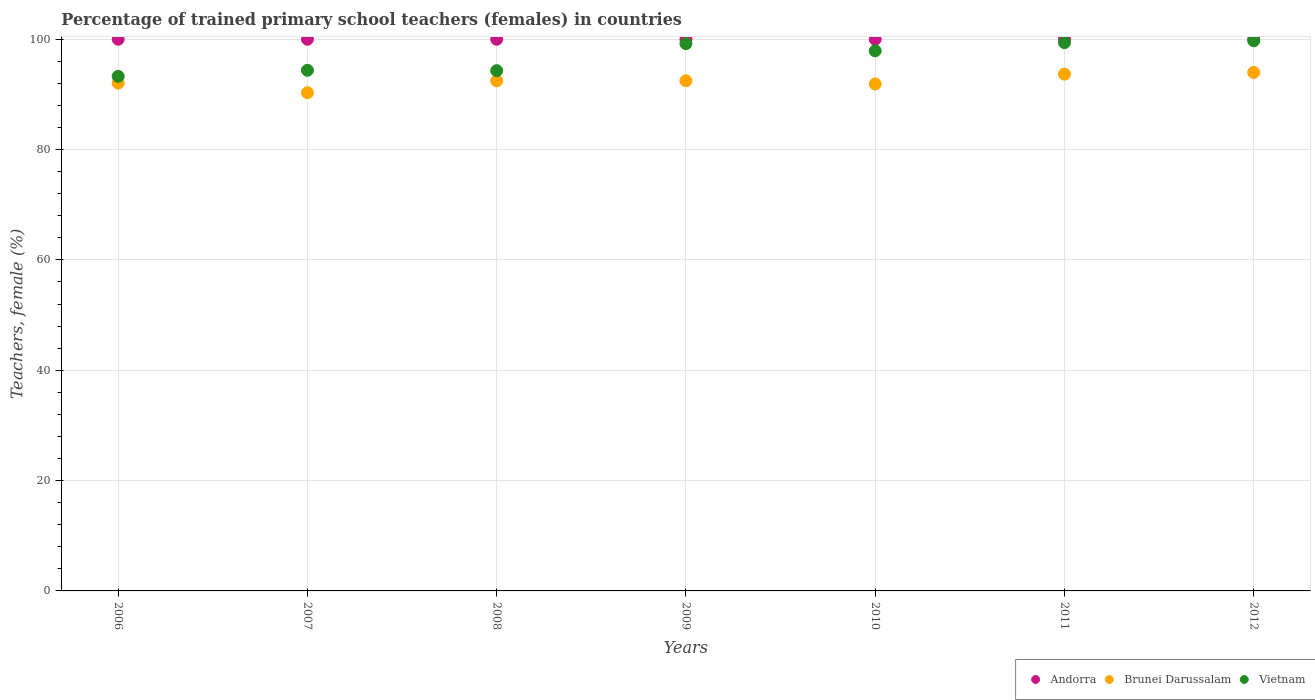How many different coloured dotlines are there?
Offer a very short reply. 3. Is the number of dotlines equal to the number of legend labels?
Your answer should be very brief. Yes. Across all years, what is the maximum percentage of trained primary school teachers (females) in Andorra?
Your answer should be very brief. 100. Across all years, what is the minimum percentage of trained primary school teachers (females) in Vietnam?
Your response must be concise. 93.27. In which year was the percentage of trained primary school teachers (females) in Vietnam minimum?
Keep it short and to the point. 2006. What is the total percentage of trained primary school teachers (females) in Brunei Darussalam in the graph?
Give a very brief answer. 646.84. What is the difference between the percentage of trained primary school teachers (females) in Andorra in 2006 and that in 2008?
Your answer should be compact. 0. What is the difference between the percentage of trained primary school teachers (females) in Vietnam in 2007 and the percentage of trained primary school teachers (females) in Brunei Darussalam in 2012?
Your answer should be compact. 0.39. What is the average percentage of trained primary school teachers (females) in Vietnam per year?
Your answer should be compact. 96.88. In the year 2008, what is the difference between the percentage of trained primary school teachers (females) in Brunei Darussalam and percentage of trained primary school teachers (females) in Andorra?
Your answer should be very brief. -7.53. In how many years, is the percentage of trained primary school teachers (females) in Brunei Darussalam greater than 52 %?
Ensure brevity in your answer.  7. Is the difference between the percentage of trained primary school teachers (females) in Brunei Darussalam in 2008 and 2009 greater than the difference between the percentage of trained primary school teachers (females) in Andorra in 2008 and 2009?
Your answer should be compact. No. What is the difference between the highest and the second highest percentage of trained primary school teachers (females) in Brunei Darussalam?
Give a very brief answer. 0.3. What is the difference between the highest and the lowest percentage of trained primary school teachers (females) in Vietnam?
Ensure brevity in your answer.  6.46. In how many years, is the percentage of trained primary school teachers (females) in Vietnam greater than the average percentage of trained primary school teachers (females) in Vietnam taken over all years?
Provide a short and direct response. 4. Is it the case that in every year, the sum of the percentage of trained primary school teachers (females) in Brunei Darussalam and percentage of trained primary school teachers (females) in Vietnam  is greater than the percentage of trained primary school teachers (females) in Andorra?
Your response must be concise. Yes. Does the percentage of trained primary school teachers (females) in Vietnam monotonically increase over the years?
Your response must be concise. No. Is the percentage of trained primary school teachers (females) in Andorra strictly greater than the percentage of trained primary school teachers (females) in Vietnam over the years?
Ensure brevity in your answer.  Yes. Is the percentage of trained primary school teachers (females) in Brunei Darussalam strictly less than the percentage of trained primary school teachers (females) in Andorra over the years?
Your answer should be compact. Yes. What is the difference between two consecutive major ticks on the Y-axis?
Ensure brevity in your answer.  20. Does the graph contain any zero values?
Provide a succinct answer. No. Does the graph contain grids?
Give a very brief answer. Yes. How are the legend labels stacked?
Offer a very short reply. Horizontal. What is the title of the graph?
Make the answer very short. Percentage of trained primary school teachers (females) in countries. What is the label or title of the Y-axis?
Your answer should be very brief. Teachers, female (%). What is the Teachers, female (%) of Andorra in 2006?
Your answer should be compact. 100. What is the Teachers, female (%) of Brunei Darussalam in 2006?
Provide a succinct answer. 92.05. What is the Teachers, female (%) of Vietnam in 2006?
Your answer should be very brief. 93.27. What is the Teachers, female (%) of Andorra in 2007?
Your answer should be very brief. 100. What is the Teachers, female (%) in Brunei Darussalam in 2007?
Offer a very short reply. 90.31. What is the Teachers, female (%) of Vietnam in 2007?
Provide a succinct answer. 94.37. What is the Teachers, female (%) in Andorra in 2008?
Provide a short and direct response. 100. What is the Teachers, female (%) in Brunei Darussalam in 2008?
Provide a succinct answer. 92.47. What is the Teachers, female (%) in Vietnam in 2008?
Your answer should be very brief. 94.31. What is the Teachers, female (%) of Andorra in 2009?
Offer a terse response. 100. What is the Teachers, female (%) in Brunei Darussalam in 2009?
Make the answer very short. 92.47. What is the Teachers, female (%) of Vietnam in 2009?
Provide a short and direct response. 99.21. What is the Teachers, female (%) of Brunei Darussalam in 2010?
Ensure brevity in your answer.  91.9. What is the Teachers, female (%) of Vietnam in 2010?
Ensure brevity in your answer.  97.9. What is the Teachers, female (%) in Andorra in 2011?
Offer a terse response. 100. What is the Teachers, female (%) of Brunei Darussalam in 2011?
Give a very brief answer. 93.68. What is the Teachers, female (%) in Vietnam in 2011?
Give a very brief answer. 99.39. What is the Teachers, female (%) of Brunei Darussalam in 2012?
Provide a succinct answer. 93.98. What is the Teachers, female (%) in Vietnam in 2012?
Provide a short and direct response. 99.73. Across all years, what is the maximum Teachers, female (%) of Andorra?
Make the answer very short. 100. Across all years, what is the maximum Teachers, female (%) in Brunei Darussalam?
Offer a very short reply. 93.98. Across all years, what is the maximum Teachers, female (%) of Vietnam?
Offer a very short reply. 99.73. Across all years, what is the minimum Teachers, female (%) of Andorra?
Your response must be concise. 100. Across all years, what is the minimum Teachers, female (%) in Brunei Darussalam?
Your answer should be very brief. 90.31. Across all years, what is the minimum Teachers, female (%) of Vietnam?
Your answer should be compact. 93.27. What is the total Teachers, female (%) in Andorra in the graph?
Offer a very short reply. 700. What is the total Teachers, female (%) in Brunei Darussalam in the graph?
Your answer should be very brief. 646.84. What is the total Teachers, female (%) of Vietnam in the graph?
Give a very brief answer. 678.18. What is the difference between the Teachers, female (%) of Brunei Darussalam in 2006 and that in 2007?
Your answer should be very brief. 1.74. What is the difference between the Teachers, female (%) in Vietnam in 2006 and that in 2007?
Give a very brief answer. -1.1. What is the difference between the Teachers, female (%) in Brunei Darussalam in 2006 and that in 2008?
Give a very brief answer. -0.42. What is the difference between the Teachers, female (%) in Vietnam in 2006 and that in 2008?
Offer a very short reply. -1.04. What is the difference between the Teachers, female (%) of Brunei Darussalam in 2006 and that in 2009?
Your answer should be compact. -0.42. What is the difference between the Teachers, female (%) of Vietnam in 2006 and that in 2009?
Your answer should be very brief. -5.93. What is the difference between the Teachers, female (%) of Brunei Darussalam in 2006 and that in 2010?
Provide a short and direct response. 0.15. What is the difference between the Teachers, female (%) of Vietnam in 2006 and that in 2010?
Offer a very short reply. -4.63. What is the difference between the Teachers, female (%) in Andorra in 2006 and that in 2011?
Give a very brief answer. 0. What is the difference between the Teachers, female (%) in Brunei Darussalam in 2006 and that in 2011?
Provide a succinct answer. -1.63. What is the difference between the Teachers, female (%) of Vietnam in 2006 and that in 2011?
Give a very brief answer. -6.12. What is the difference between the Teachers, female (%) in Andorra in 2006 and that in 2012?
Offer a very short reply. 0. What is the difference between the Teachers, female (%) of Brunei Darussalam in 2006 and that in 2012?
Your answer should be very brief. -1.93. What is the difference between the Teachers, female (%) of Vietnam in 2006 and that in 2012?
Your answer should be very brief. -6.46. What is the difference between the Teachers, female (%) of Andorra in 2007 and that in 2008?
Offer a very short reply. 0. What is the difference between the Teachers, female (%) of Brunei Darussalam in 2007 and that in 2008?
Make the answer very short. -2.16. What is the difference between the Teachers, female (%) of Vietnam in 2007 and that in 2008?
Your answer should be compact. 0.07. What is the difference between the Teachers, female (%) in Andorra in 2007 and that in 2009?
Your answer should be compact. 0. What is the difference between the Teachers, female (%) of Brunei Darussalam in 2007 and that in 2009?
Offer a very short reply. -2.16. What is the difference between the Teachers, female (%) of Vietnam in 2007 and that in 2009?
Offer a terse response. -4.83. What is the difference between the Teachers, female (%) of Andorra in 2007 and that in 2010?
Keep it short and to the point. 0. What is the difference between the Teachers, female (%) in Brunei Darussalam in 2007 and that in 2010?
Ensure brevity in your answer.  -1.59. What is the difference between the Teachers, female (%) in Vietnam in 2007 and that in 2010?
Give a very brief answer. -3.53. What is the difference between the Teachers, female (%) in Brunei Darussalam in 2007 and that in 2011?
Provide a short and direct response. -3.37. What is the difference between the Teachers, female (%) in Vietnam in 2007 and that in 2011?
Offer a very short reply. -5.01. What is the difference between the Teachers, female (%) of Andorra in 2007 and that in 2012?
Provide a short and direct response. 0. What is the difference between the Teachers, female (%) in Brunei Darussalam in 2007 and that in 2012?
Provide a short and direct response. -3.67. What is the difference between the Teachers, female (%) in Vietnam in 2007 and that in 2012?
Offer a very short reply. -5.36. What is the difference between the Teachers, female (%) in Brunei Darussalam in 2008 and that in 2009?
Ensure brevity in your answer.  -0. What is the difference between the Teachers, female (%) of Vietnam in 2008 and that in 2009?
Keep it short and to the point. -4.9. What is the difference between the Teachers, female (%) of Brunei Darussalam in 2008 and that in 2010?
Make the answer very short. 0.57. What is the difference between the Teachers, female (%) in Vietnam in 2008 and that in 2010?
Provide a succinct answer. -3.59. What is the difference between the Teachers, female (%) of Andorra in 2008 and that in 2011?
Your response must be concise. 0. What is the difference between the Teachers, female (%) in Brunei Darussalam in 2008 and that in 2011?
Offer a terse response. -1.21. What is the difference between the Teachers, female (%) of Vietnam in 2008 and that in 2011?
Keep it short and to the point. -5.08. What is the difference between the Teachers, female (%) in Andorra in 2008 and that in 2012?
Your answer should be compact. 0. What is the difference between the Teachers, female (%) of Brunei Darussalam in 2008 and that in 2012?
Give a very brief answer. -1.51. What is the difference between the Teachers, female (%) of Vietnam in 2008 and that in 2012?
Provide a succinct answer. -5.42. What is the difference between the Teachers, female (%) of Brunei Darussalam in 2009 and that in 2010?
Keep it short and to the point. 0.57. What is the difference between the Teachers, female (%) in Vietnam in 2009 and that in 2010?
Provide a succinct answer. 1.31. What is the difference between the Teachers, female (%) of Andorra in 2009 and that in 2011?
Provide a short and direct response. 0. What is the difference between the Teachers, female (%) of Brunei Darussalam in 2009 and that in 2011?
Your response must be concise. -1.21. What is the difference between the Teachers, female (%) of Vietnam in 2009 and that in 2011?
Provide a succinct answer. -0.18. What is the difference between the Teachers, female (%) of Brunei Darussalam in 2009 and that in 2012?
Your answer should be very brief. -1.51. What is the difference between the Teachers, female (%) in Vietnam in 2009 and that in 2012?
Provide a short and direct response. -0.53. What is the difference between the Teachers, female (%) in Andorra in 2010 and that in 2011?
Your answer should be very brief. 0. What is the difference between the Teachers, female (%) in Brunei Darussalam in 2010 and that in 2011?
Your answer should be very brief. -1.78. What is the difference between the Teachers, female (%) in Vietnam in 2010 and that in 2011?
Your answer should be very brief. -1.49. What is the difference between the Teachers, female (%) of Brunei Darussalam in 2010 and that in 2012?
Provide a short and direct response. -2.08. What is the difference between the Teachers, female (%) of Vietnam in 2010 and that in 2012?
Offer a very short reply. -1.83. What is the difference between the Teachers, female (%) in Andorra in 2011 and that in 2012?
Ensure brevity in your answer.  0. What is the difference between the Teachers, female (%) in Brunei Darussalam in 2011 and that in 2012?
Provide a short and direct response. -0.3. What is the difference between the Teachers, female (%) in Vietnam in 2011 and that in 2012?
Give a very brief answer. -0.34. What is the difference between the Teachers, female (%) in Andorra in 2006 and the Teachers, female (%) in Brunei Darussalam in 2007?
Keep it short and to the point. 9.69. What is the difference between the Teachers, female (%) in Andorra in 2006 and the Teachers, female (%) in Vietnam in 2007?
Offer a terse response. 5.63. What is the difference between the Teachers, female (%) of Brunei Darussalam in 2006 and the Teachers, female (%) of Vietnam in 2007?
Offer a terse response. -2.33. What is the difference between the Teachers, female (%) in Andorra in 2006 and the Teachers, female (%) in Brunei Darussalam in 2008?
Keep it short and to the point. 7.53. What is the difference between the Teachers, female (%) of Andorra in 2006 and the Teachers, female (%) of Vietnam in 2008?
Provide a short and direct response. 5.69. What is the difference between the Teachers, female (%) in Brunei Darussalam in 2006 and the Teachers, female (%) in Vietnam in 2008?
Provide a short and direct response. -2.26. What is the difference between the Teachers, female (%) in Andorra in 2006 and the Teachers, female (%) in Brunei Darussalam in 2009?
Offer a terse response. 7.53. What is the difference between the Teachers, female (%) in Andorra in 2006 and the Teachers, female (%) in Vietnam in 2009?
Make the answer very short. 0.79. What is the difference between the Teachers, female (%) of Brunei Darussalam in 2006 and the Teachers, female (%) of Vietnam in 2009?
Your response must be concise. -7.16. What is the difference between the Teachers, female (%) of Andorra in 2006 and the Teachers, female (%) of Brunei Darussalam in 2010?
Make the answer very short. 8.1. What is the difference between the Teachers, female (%) of Andorra in 2006 and the Teachers, female (%) of Vietnam in 2010?
Keep it short and to the point. 2.1. What is the difference between the Teachers, female (%) in Brunei Darussalam in 2006 and the Teachers, female (%) in Vietnam in 2010?
Provide a short and direct response. -5.85. What is the difference between the Teachers, female (%) of Andorra in 2006 and the Teachers, female (%) of Brunei Darussalam in 2011?
Make the answer very short. 6.32. What is the difference between the Teachers, female (%) of Andorra in 2006 and the Teachers, female (%) of Vietnam in 2011?
Provide a short and direct response. 0.61. What is the difference between the Teachers, female (%) in Brunei Darussalam in 2006 and the Teachers, female (%) in Vietnam in 2011?
Keep it short and to the point. -7.34. What is the difference between the Teachers, female (%) of Andorra in 2006 and the Teachers, female (%) of Brunei Darussalam in 2012?
Provide a short and direct response. 6.02. What is the difference between the Teachers, female (%) in Andorra in 2006 and the Teachers, female (%) in Vietnam in 2012?
Your response must be concise. 0.27. What is the difference between the Teachers, female (%) in Brunei Darussalam in 2006 and the Teachers, female (%) in Vietnam in 2012?
Your response must be concise. -7.68. What is the difference between the Teachers, female (%) of Andorra in 2007 and the Teachers, female (%) of Brunei Darussalam in 2008?
Offer a very short reply. 7.53. What is the difference between the Teachers, female (%) of Andorra in 2007 and the Teachers, female (%) of Vietnam in 2008?
Make the answer very short. 5.69. What is the difference between the Teachers, female (%) of Brunei Darussalam in 2007 and the Teachers, female (%) of Vietnam in 2008?
Offer a terse response. -4. What is the difference between the Teachers, female (%) in Andorra in 2007 and the Teachers, female (%) in Brunei Darussalam in 2009?
Provide a short and direct response. 7.53. What is the difference between the Teachers, female (%) in Andorra in 2007 and the Teachers, female (%) in Vietnam in 2009?
Offer a terse response. 0.79. What is the difference between the Teachers, female (%) of Brunei Darussalam in 2007 and the Teachers, female (%) of Vietnam in 2009?
Make the answer very short. -8.9. What is the difference between the Teachers, female (%) of Andorra in 2007 and the Teachers, female (%) of Brunei Darussalam in 2010?
Make the answer very short. 8.1. What is the difference between the Teachers, female (%) in Andorra in 2007 and the Teachers, female (%) in Vietnam in 2010?
Give a very brief answer. 2.1. What is the difference between the Teachers, female (%) in Brunei Darussalam in 2007 and the Teachers, female (%) in Vietnam in 2010?
Give a very brief answer. -7.59. What is the difference between the Teachers, female (%) of Andorra in 2007 and the Teachers, female (%) of Brunei Darussalam in 2011?
Your answer should be compact. 6.32. What is the difference between the Teachers, female (%) in Andorra in 2007 and the Teachers, female (%) in Vietnam in 2011?
Ensure brevity in your answer.  0.61. What is the difference between the Teachers, female (%) of Brunei Darussalam in 2007 and the Teachers, female (%) of Vietnam in 2011?
Give a very brief answer. -9.08. What is the difference between the Teachers, female (%) of Andorra in 2007 and the Teachers, female (%) of Brunei Darussalam in 2012?
Your answer should be compact. 6.02. What is the difference between the Teachers, female (%) of Andorra in 2007 and the Teachers, female (%) of Vietnam in 2012?
Offer a terse response. 0.27. What is the difference between the Teachers, female (%) of Brunei Darussalam in 2007 and the Teachers, female (%) of Vietnam in 2012?
Ensure brevity in your answer.  -9.42. What is the difference between the Teachers, female (%) of Andorra in 2008 and the Teachers, female (%) of Brunei Darussalam in 2009?
Your answer should be compact. 7.53. What is the difference between the Teachers, female (%) of Andorra in 2008 and the Teachers, female (%) of Vietnam in 2009?
Your response must be concise. 0.79. What is the difference between the Teachers, female (%) in Brunei Darussalam in 2008 and the Teachers, female (%) in Vietnam in 2009?
Your response must be concise. -6.74. What is the difference between the Teachers, female (%) of Andorra in 2008 and the Teachers, female (%) of Brunei Darussalam in 2010?
Provide a short and direct response. 8.1. What is the difference between the Teachers, female (%) in Andorra in 2008 and the Teachers, female (%) in Vietnam in 2010?
Your answer should be compact. 2.1. What is the difference between the Teachers, female (%) in Brunei Darussalam in 2008 and the Teachers, female (%) in Vietnam in 2010?
Your answer should be very brief. -5.43. What is the difference between the Teachers, female (%) in Andorra in 2008 and the Teachers, female (%) in Brunei Darussalam in 2011?
Offer a very short reply. 6.32. What is the difference between the Teachers, female (%) in Andorra in 2008 and the Teachers, female (%) in Vietnam in 2011?
Give a very brief answer. 0.61. What is the difference between the Teachers, female (%) in Brunei Darussalam in 2008 and the Teachers, female (%) in Vietnam in 2011?
Provide a short and direct response. -6.92. What is the difference between the Teachers, female (%) of Andorra in 2008 and the Teachers, female (%) of Brunei Darussalam in 2012?
Your response must be concise. 6.02. What is the difference between the Teachers, female (%) in Andorra in 2008 and the Teachers, female (%) in Vietnam in 2012?
Ensure brevity in your answer.  0.27. What is the difference between the Teachers, female (%) in Brunei Darussalam in 2008 and the Teachers, female (%) in Vietnam in 2012?
Your answer should be compact. -7.26. What is the difference between the Teachers, female (%) of Andorra in 2009 and the Teachers, female (%) of Brunei Darussalam in 2010?
Your response must be concise. 8.1. What is the difference between the Teachers, female (%) of Andorra in 2009 and the Teachers, female (%) of Vietnam in 2010?
Provide a succinct answer. 2.1. What is the difference between the Teachers, female (%) in Brunei Darussalam in 2009 and the Teachers, female (%) in Vietnam in 2010?
Give a very brief answer. -5.43. What is the difference between the Teachers, female (%) in Andorra in 2009 and the Teachers, female (%) in Brunei Darussalam in 2011?
Your answer should be very brief. 6.32. What is the difference between the Teachers, female (%) in Andorra in 2009 and the Teachers, female (%) in Vietnam in 2011?
Make the answer very short. 0.61. What is the difference between the Teachers, female (%) of Brunei Darussalam in 2009 and the Teachers, female (%) of Vietnam in 2011?
Offer a very short reply. -6.92. What is the difference between the Teachers, female (%) of Andorra in 2009 and the Teachers, female (%) of Brunei Darussalam in 2012?
Provide a succinct answer. 6.02. What is the difference between the Teachers, female (%) of Andorra in 2009 and the Teachers, female (%) of Vietnam in 2012?
Your answer should be very brief. 0.27. What is the difference between the Teachers, female (%) in Brunei Darussalam in 2009 and the Teachers, female (%) in Vietnam in 2012?
Give a very brief answer. -7.26. What is the difference between the Teachers, female (%) in Andorra in 2010 and the Teachers, female (%) in Brunei Darussalam in 2011?
Offer a very short reply. 6.32. What is the difference between the Teachers, female (%) of Andorra in 2010 and the Teachers, female (%) of Vietnam in 2011?
Ensure brevity in your answer.  0.61. What is the difference between the Teachers, female (%) in Brunei Darussalam in 2010 and the Teachers, female (%) in Vietnam in 2011?
Offer a terse response. -7.49. What is the difference between the Teachers, female (%) in Andorra in 2010 and the Teachers, female (%) in Brunei Darussalam in 2012?
Ensure brevity in your answer.  6.02. What is the difference between the Teachers, female (%) in Andorra in 2010 and the Teachers, female (%) in Vietnam in 2012?
Keep it short and to the point. 0.27. What is the difference between the Teachers, female (%) in Brunei Darussalam in 2010 and the Teachers, female (%) in Vietnam in 2012?
Keep it short and to the point. -7.83. What is the difference between the Teachers, female (%) of Andorra in 2011 and the Teachers, female (%) of Brunei Darussalam in 2012?
Provide a short and direct response. 6.02. What is the difference between the Teachers, female (%) of Andorra in 2011 and the Teachers, female (%) of Vietnam in 2012?
Provide a succinct answer. 0.27. What is the difference between the Teachers, female (%) of Brunei Darussalam in 2011 and the Teachers, female (%) of Vietnam in 2012?
Offer a terse response. -6.05. What is the average Teachers, female (%) in Andorra per year?
Your answer should be compact. 100. What is the average Teachers, female (%) in Brunei Darussalam per year?
Your answer should be very brief. 92.41. What is the average Teachers, female (%) in Vietnam per year?
Offer a very short reply. 96.88. In the year 2006, what is the difference between the Teachers, female (%) of Andorra and Teachers, female (%) of Brunei Darussalam?
Your answer should be very brief. 7.95. In the year 2006, what is the difference between the Teachers, female (%) of Andorra and Teachers, female (%) of Vietnam?
Your answer should be very brief. 6.73. In the year 2006, what is the difference between the Teachers, female (%) of Brunei Darussalam and Teachers, female (%) of Vietnam?
Your answer should be very brief. -1.22. In the year 2007, what is the difference between the Teachers, female (%) of Andorra and Teachers, female (%) of Brunei Darussalam?
Provide a short and direct response. 9.69. In the year 2007, what is the difference between the Teachers, female (%) of Andorra and Teachers, female (%) of Vietnam?
Make the answer very short. 5.63. In the year 2007, what is the difference between the Teachers, female (%) in Brunei Darussalam and Teachers, female (%) in Vietnam?
Your answer should be compact. -4.07. In the year 2008, what is the difference between the Teachers, female (%) in Andorra and Teachers, female (%) in Brunei Darussalam?
Provide a succinct answer. 7.53. In the year 2008, what is the difference between the Teachers, female (%) of Andorra and Teachers, female (%) of Vietnam?
Offer a terse response. 5.69. In the year 2008, what is the difference between the Teachers, female (%) in Brunei Darussalam and Teachers, female (%) in Vietnam?
Your answer should be compact. -1.84. In the year 2009, what is the difference between the Teachers, female (%) of Andorra and Teachers, female (%) of Brunei Darussalam?
Make the answer very short. 7.53. In the year 2009, what is the difference between the Teachers, female (%) of Andorra and Teachers, female (%) of Vietnam?
Keep it short and to the point. 0.79. In the year 2009, what is the difference between the Teachers, female (%) in Brunei Darussalam and Teachers, female (%) in Vietnam?
Give a very brief answer. -6.74. In the year 2010, what is the difference between the Teachers, female (%) in Andorra and Teachers, female (%) in Brunei Darussalam?
Make the answer very short. 8.1. In the year 2010, what is the difference between the Teachers, female (%) in Andorra and Teachers, female (%) in Vietnam?
Your answer should be very brief. 2.1. In the year 2010, what is the difference between the Teachers, female (%) of Brunei Darussalam and Teachers, female (%) of Vietnam?
Your answer should be compact. -6. In the year 2011, what is the difference between the Teachers, female (%) in Andorra and Teachers, female (%) in Brunei Darussalam?
Offer a terse response. 6.32. In the year 2011, what is the difference between the Teachers, female (%) in Andorra and Teachers, female (%) in Vietnam?
Provide a succinct answer. 0.61. In the year 2011, what is the difference between the Teachers, female (%) in Brunei Darussalam and Teachers, female (%) in Vietnam?
Offer a very short reply. -5.71. In the year 2012, what is the difference between the Teachers, female (%) of Andorra and Teachers, female (%) of Brunei Darussalam?
Ensure brevity in your answer.  6.02. In the year 2012, what is the difference between the Teachers, female (%) of Andorra and Teachers, female (%) of Vietnam?
Make the answer very short. 0.27. In the year 2012, what is the difference between the Teachers, female (%) in Brunei Darussalam and Teachers, female (%) in Vietnam?
Make the answer very short. -5.75. What is the ratio of the Teachers, female (%) in Brunei Darussalam in 2006 to that in 2007?
Keep it short and to the point. 1.02. What is the ratio of the Teachers, female (%) of Vietnam in 2006 to that in 2007?
Ensure brevity in your answer.  0.99. What is the ratio of the Teachers, female (%) in Andorra in 2006 to that in 2009?
Your response must be concise. 1. What is the ratio of the Teachers, female (%) in Vietnam in 2006 to that in 2009?
Give a very brief answer. 0.94. What is the ratio of the Teachers, female (%) in Vietnam in 2006 to that in 2010?
Your answer should be compact. 0.95. What is the ratio of the Teachers, female (%) of Brunei Darussalam in 2006 to that in 2011?
Offer a terse response. 0.98. What is the ratio of the Teachers, female (%) of Vietnam in 2006 to that in 2011?
Ensure brevity in your answer.  0.94. What is the ratio of the Teachers, female (%) in Andorra in 2006 to that in 2012?
Offer a terse response. 1. What is the ratio of the Teachers, female (%) in Brunei Darussalam in 2006 to that in 2012?
Keep it short and to the point. 0.98. What is the ratio of the Teachers, female (%) in Vietnam in 2006 to that in 2012?
Make the answer very short. 0.94. What is the ratio of the Teachers, female (%) in Brunei Darussalam in 2007 to that in 2008?
Provide a short and direct response. 0.98. What is the ratio of the Teachers, female (%) of Vietnam in 2007 to that in 2008?
Provide a succinct answer. 1. What is the ratio of the Teachers, female (%) in Andorra in 2007 to that in 2009?
Provide a short and direct response. 1. What is the ratio of the Teachers, female (%) in Brunei Darussalam in 2007 to that in 2009?
Make the answer very short. 0.98. What is the ratio of the Teachers, female (%) in Vietnam in 2007 to that in 2009?
Provide a succinct answer. 0.95. What is the ratio of the Teachers, female (%) in Andorra in 2007 to that in 2010?
Give a very brief answer. 1. What is the ratio of the Teachers, female (%) of Brunei Darussalam in 2007 to that in 2010?
Your answer should be compact. 0.98. What is the ratio of the Teachers, female (%) of Brunei Darussalam in 2007 to that in 2011?
Keep it short and to the point. 0.96. What is the ratio of the Teachers, female (%) of Vietnam in 2007 to that in 2011?
Keep it short and to the point. 0.95. What is the ratio of the Teachers, female (%) in Andorra in 2007 to that in 2012?
Ensure brevity in your answer.  1. What is the ratio of the Teachers, female (%) in Brunei Darussalam in 2007 to that in 2012?
Your response must be concise. 0.96. What is the ratio of the Teachers, female (%) in Vietnam in 2007 to that in 2012?
Your answer should be very brief. 0.95. What is the ratio of the Teachers, female (%) in Andorra in 2008 to that in 2009?
Your answer should be compact. 1. What is the ratio of the Teachers, female (%) of Brunei Darussalam in 2008 to that in 2009?
Your answer should be very brief. 1. What is the ratio of the Teachers, female (%) in Vietnam in 2008 to that in 2009?
Offer a very short reply. 0.95. What is the ratio of the Teachers, female (%) in Brunei Darussalam in 2008 to that in 2010?
Ensure brevity in your answer.  1.01. What is the ratio of the Teachers, female (%) in Vietnam in 2008 to that in 2010?
Offer a terse response. 0.96. What is the ratio of the Teachers, female (%) in Andorra in 2008 to that in 2011?
Your answer should be very brief. 1. What is the ratio of the Teachers, female (%) in Brunei Darussalam in 2008 to that in 2011?
Give a very brief answer. 0.99. What is the ratio of the Teachers, female (%) in Vietnam in 2008 to that in 2011?
Your response must be concise. 0.95. What is the ratio of the Teachers, female (%) in Andorra in 2008 to that in 2012?
Provide a succinct answer. 1. What is the ratio of the Teachers, female (%) in Brunei Darussalam in 2008 to that in 2012?
Give a very brief answer. 0.98. What is the ratio of the Teachers, female (%) in Vietnam in 2008 to that in 2012?
Your response must be concise. 0.95. What is the ratio of the Teachers, female (%) in Vietnam in 2009 to that in 2010?
Offer a very short reply. 1.01. What is the ratio of the Teachers, female (%) in Andorra in 2009 to that in 2011?
Make the answer very short. 1. What is the ratio of the Teachers, female (%) in Brunei Darussalam in 2009 to that in 2011?
Your response must be concise. 0.99. What is the ratio of the Teachers, female (%) of Andorra in 2009 to that in 2012?
Offer a very short reply. 1. What is the ratio of the Teachers, female (%) in Brunei Darussalam in 2009 to that in 2012?
Ensure brevity in your answer.  0.98. What is the ratio of the Teachers, female (%) in Andorra in 2010 to that in 2012?
Ensure brevity in your answer.  1. What is the ratio of the Teachers, female (%) of Brunei Darussalam in 2010 to that in 2012?
Keep it short and to the point. 0.98. What is the ratio of the Teachers, female (%) of Vietnam in 2010 to that in 2012?
Ensure brevity in your answer.  0.98. What is the ratio of the Teachers, female (%) of Andorra in 2011 to that in 2012?
Offer a very short reply. 1. What is the ratio of the Teachers, female (%) in Brunei Darussalam in 2011 to that in 2012?
Ensure brevity in your answer.  1. What is the difference between the highest and the second highest Teachers, female (%) of Brunei Darussalam?
Offer a terse response. 0.3. What is the difference between the highest and the second highest Teachers, female (%) of Vietnam?
Keep it short and to the point. 0.34. What is the difference between the highest and the lowest Teachers, female (%) in Brunei Darussalam?
Your answer should be compact. 3.67. What is the difference between the highest and the lowest Teachers, female (%) in Vietnam?
Provide a short and direct response. 6.46. 